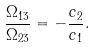<formula> <loc_0><loc_0><loc_500><loc_500>\frac { \Omega _ { 1 3 } } { \Omega _ { 2 3 } } = - \frac { c _ { 2 } } { c _ { 1 } } .</formula> 